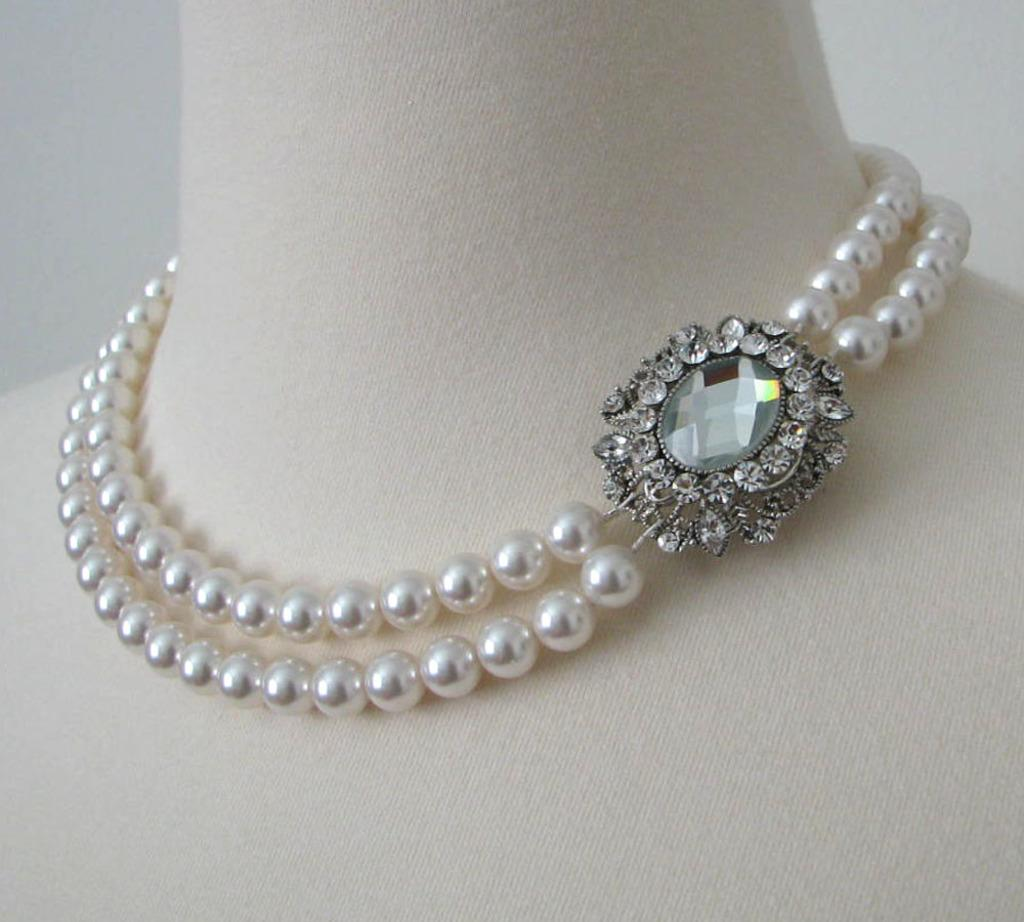What is the main object in the image? There is an ornament in the image. Where is the ornament located? The ornament is on a mannequin. What type of oatmeal is being served to the woman in the image? There is no woman or oatmeal present in the image; it features an ornament on a mannequin. Can you describe the zebra's pattern in the image? There is no zebra present in the image. 